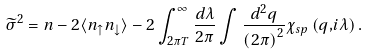Convert formula to latex. <formula><loc_0><loc_0><loc_500><loc_500>\widetilde { \sigma } ^ { 2 } = n - 2 \langle n _ { \uparrow } n _ { \downarrow } \rangle - 2 \int _ { 2 \pi T } ^ { \infty } \frac { d \lambda } { 2 \pi } \int \frac { d ^ { 2 } q } { \left ( 2 \pi \right ) ^ { 2 } } \chi _ { s p } \left ( { q , } i \lambda \right ) .</formula> 